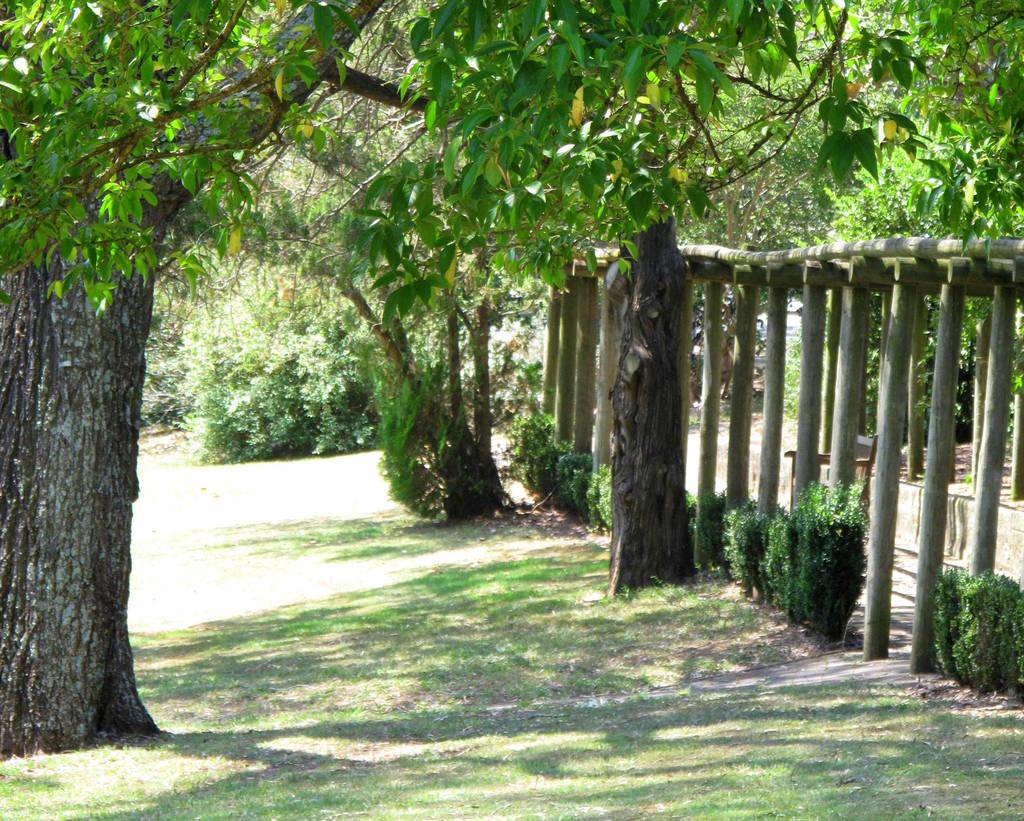What type of vegetation can be seen in the image? There are trees, plants, and grass in the image. What else is present in the image besides vegetation? There are poles in the image. How many lizards can be seen crawling on the grass in the image? There are no lizards present in the image. What sound does the alarm make in the image? There is no alarm present in the image. 